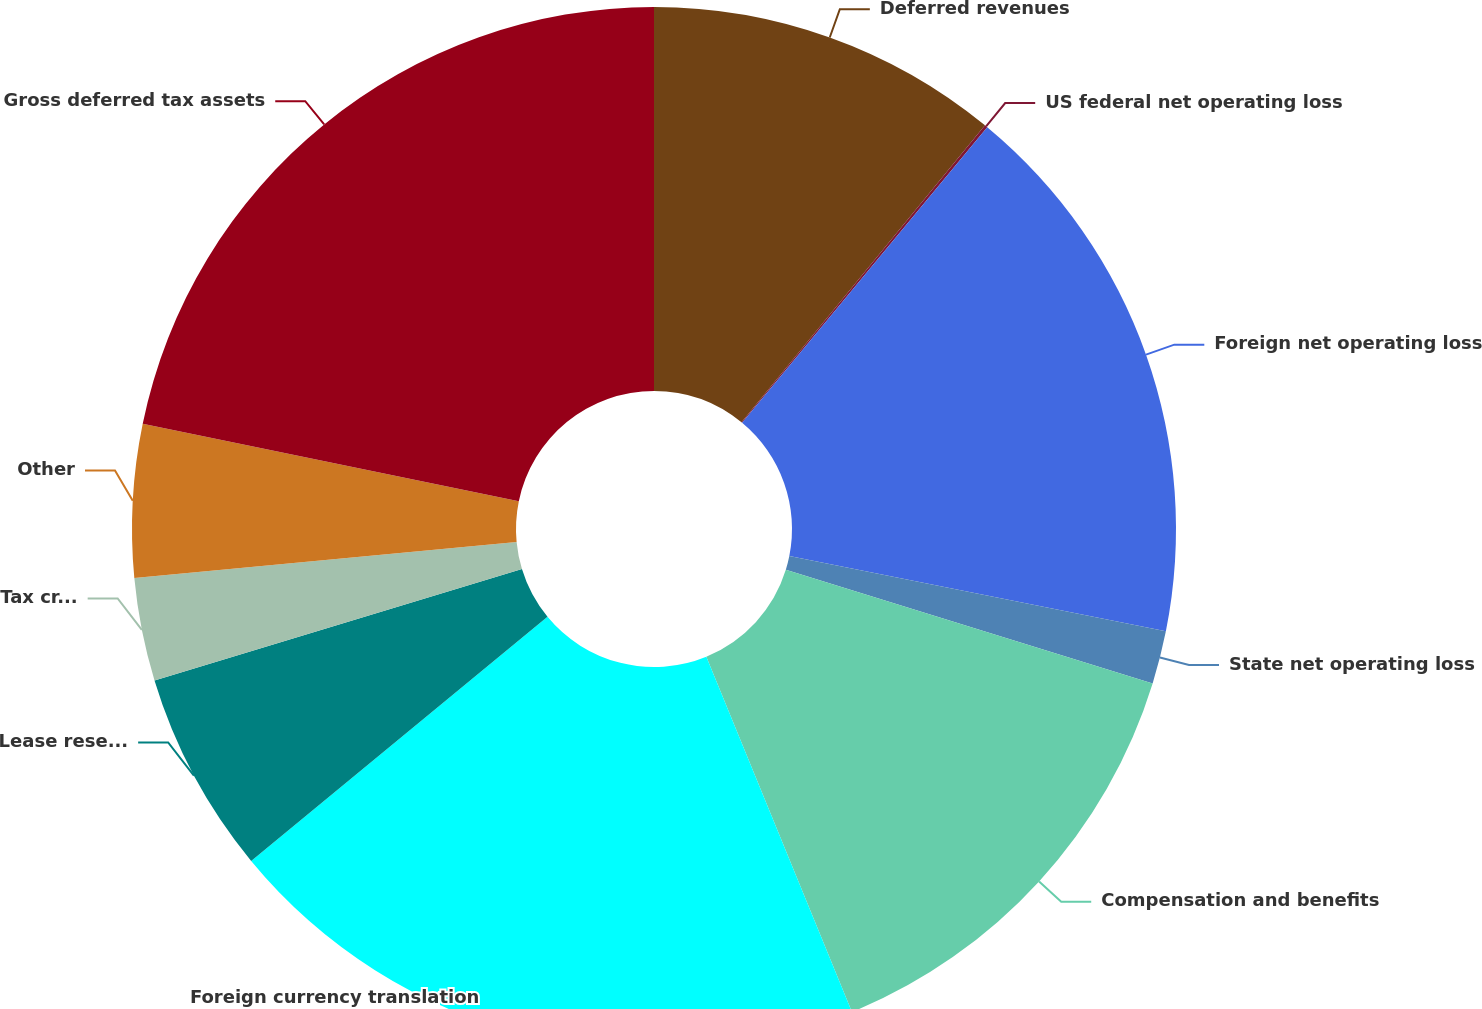<chart> <loc_0><loc_0><loc_500><loc_500><pie_chart><fcel>Deferred revenues<fcel>US federal net operating loss<fcel>Foreign net operating loss<fcel>State net operating loss<fcel>Compensation and benefits<fcel>Foreign currency translation<fcel>Lease reserves<fcel>Tax credits<fcel>Other<fcel>Gross deferred tax assets<nl><fcel>10.93%<fcel>0.09%<fcel>17.12%<fcel>1.64%<fcel>14.03%<fcel>20.22%<fcel>6.28%<fcel>3.19%<fcel>4.73%<fcel>21.77%<nl></chart> 